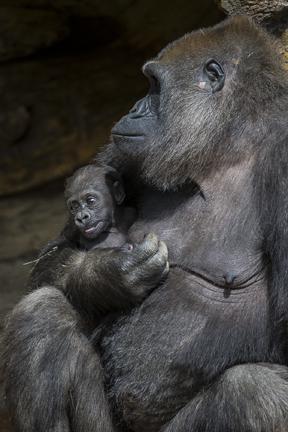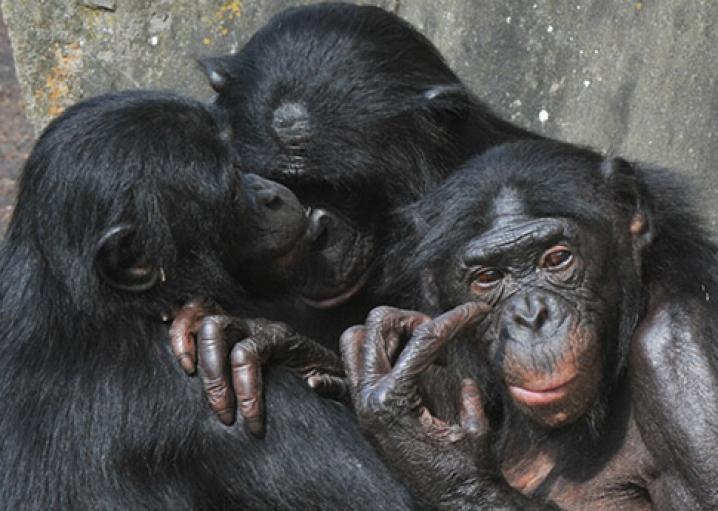The first image is the image on the left, the second image is the image on the right. For the images shown, is this caption "A female ape is holding a baby ape." true? Answer yes or no. Yes. The first image is the image on the left, the second image is the image on the right. Evaluate the accuracy of this statement regarding the images: "One image contains a group of three apes, and the other image features one adult gorilla sitting with a baby gorilla that is on the adult's chest and facing forward.". Is it true? Answer yes or no. Yes. 